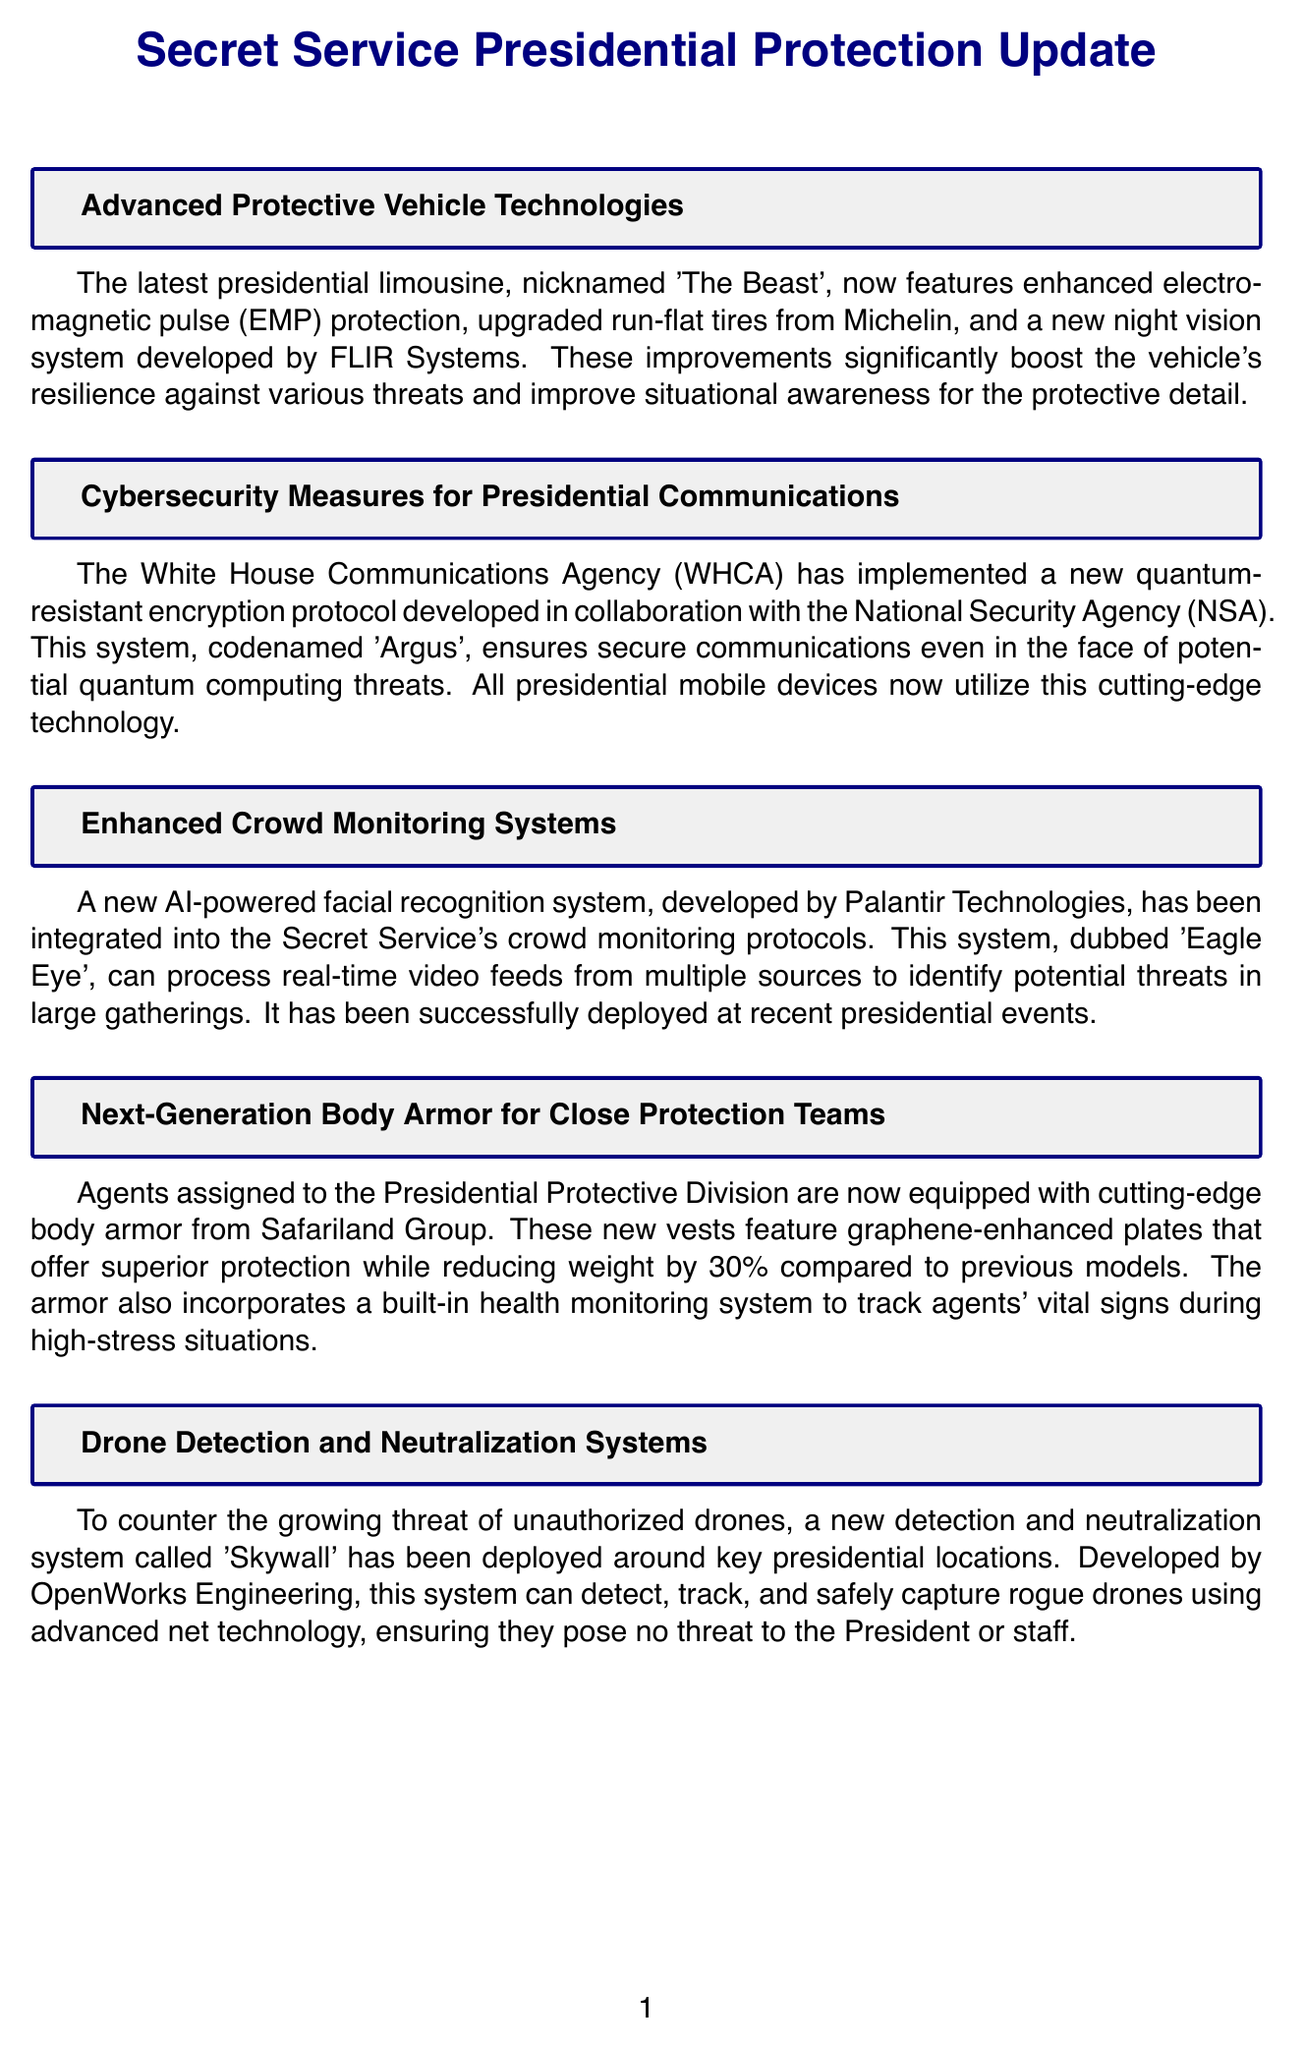What is the new encryption protocol for presidential communications? The document states that the new encryption protocol is codenamed 'Argus', developed in collaboration with the NSA.
Answer: Argus What company developed the facial recognition system 'Eagle Eye'? The document mentions that the facial recognition system was developed by Palantir Technologies.
Answer: Palantir Technologies How much lighter is the new body armor compared to previous models? The document indicates that the new body armor reduces weight by 30%.
Answer: 30% What system is used to detect and capture rogue drones? The newsletter specifies that the system used is called 'Skywall'.
Answer: Skywall What feature enhances the nighttime visibility of 'The Beast'? According to the document, 'The Beast' features a new night vision system developed by FLIR Systems to enhance nighttime visibility.
Answer: night vision system Which agency implemented the advancements for presidential cybersecurity? The document states that the White House Communications Agency (WHCA) implemented the advancements.
Answer: White House Communications Agency 